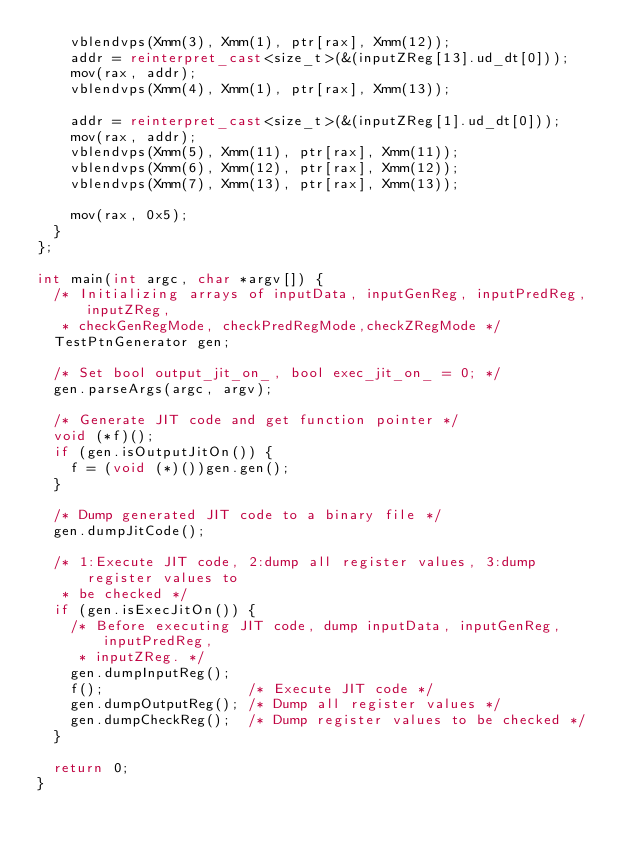Convert code to text. <code><loc_0><loc_0><loc_500><loc_500><_C++_>    vblendvps(Xmm(3), Xmm(1), ptr[rax], Xmm(12));
    addr = reinterpret_cast<size_t>(&(inputZReg[13].ud_dt[0]));
    mov(rax, addr);
    vblendvps(Xmm(4), Xmm(1), ptr[rax], Xmm(13));

    addr = reinterpret_cast<size_t>(&(inputZReg[1].ud_dt[0]));
    mov(rax, addr);
    vblendvps(Xmm(5), Xmm(11), ptr[rax], Xmm(11));
    vblendvps(Xmm(6), Xmm(12), ptr[rax], Xmm(12));
    vblendvps(Xmm(7), Xmm(13), ptr[rax], Xmm(13));

    mov(rax, 0x5);
  }
};

int main(int argc, char *argv[]) {
  /* Initializing arrays of inputData, inputGenReg, inputPredReg, inputZReg,
   * checkGenRegMode, checkPredRegMode,checkZRegMode */
  TestPtnGenerator gen;

  /* Set bool output_jit_on_, bool exec_jit_on_ = 0; */
  gen.parseArgs(argc, argv);

  /* Generate JIT code and get function pointer */
  void (*f)();
  if (gen.isOutputJitOn()) {
    f = (void (*)())gen.gen();
  }

  /* Dump generated JIT code to a binary file */
  gen.dumpJitCode();

  /* 1:Execute JIT code, 2:dump all register values, 3:dump register values to
   * be checked */
  if (gen.isExecJitOn()) {
    /* Before executing JIT code, dump inputData, inputGenReg, inputPredReg,
     * inputZReg. */
    gen.dumpInputReg();
    f();                 /* Execute JIT code */
    gen.dumpOutputReg(); /* Dump all register values */
    gen.dumpCheckReg();  /* Dump register values to be checked */
  }

  return 0;
}
</code> 